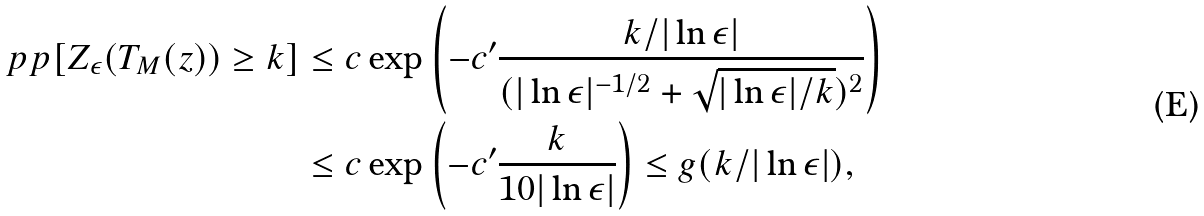<formula> <loc_0><loc_0><loc_500><loc_500>\ p p [ Z _ { \epsilon } ( T _ { M } ( z ) ) \geq k ] & \leq c \exp \left ( - c ^ { \prime } \frac { k / | \ln \epsilon | } { ( | \ln \epsilon | ^ { - 1 / 2 } + \sqrt { | \ln \epsilon | / k } ) ^ { 2 } } \right ) \\ & \leq c \exp \left ( - c ^ { \prime } \frac { k } { 1 0 | \ln \epsilon | } \right ) \leq g ( k / | \ln \epsilon | ) ,</formula> 